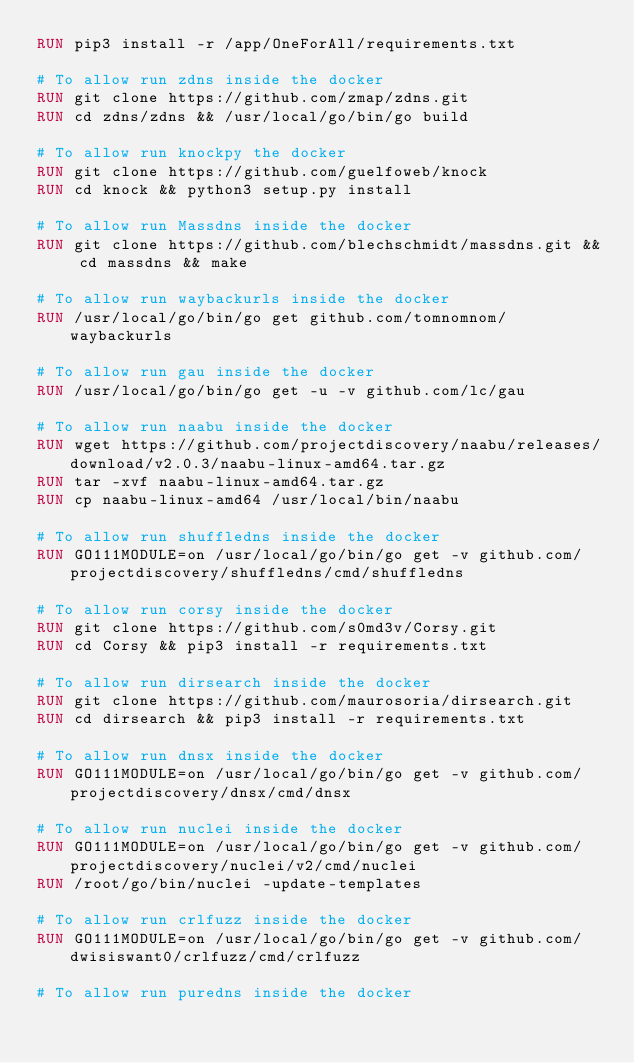<code> <loc_0><loc_0><loc_500><loc_500><_Dockerfile_>RUN pip3 install -r /app/OneForAll/requirements.txt

# To allow run zdns inside the docker
RUN git clone https://github.com/zmap/zdns.git
RUN cd zdns/zdns && /usr/local/go/bin/go build

# To allow run knockpy the docker
RUN git clone https://github.com/guelfoweb/knock
RUN cd knock && python3 setup.py install

# To allow run Massdns inside the docker
RUN git clone https://github.com/blechschmidt/massdns.git && cd massdns && make

# To allow run waybackurls inside the docker
RUN /usr/local/go/bin/go get github.com/tomnomnom/waybackurls

# To allow run gau inside the docker
RUN /usr/local/go/bin/go get -u -v github.com/lc/gau

# To allow run naabu inside the docker
RUN wget https://github.com/projectdiscovery/naabu/releases/download/v2.0.3/naabu-linux-amd64.tar.gz
RUN tar -xvf naabu-linux-amd64.tar.gz
RUN cp naabu-linux-amd64 /usr/local/bin/naabu

# To allow run shuffledns inside the docker
RUN GO111MODULE=on /usr/local/go/bin/go get -v github.com/projectdiscovery/shuffledns/cmd/shuffledns

# To allow run corsy inside the docker
RUN git clone https://github.com/s0md3v/Corsy.git
RUN cd Corsy && pip3 install -r requirements.txt

# To allow run dirsearch inside the docker
RUN git clone https://github.com/maurosoria/dirsearch.git
RUN cd dirsearch && pip3 install -r requirements.txt

# To allow run dnsx inside the docker
RUN GO111MODULE=on /usr/local/go/bin/go get -v github.com/projectdiscovery/dnsx/cmd/dnsx

# To allow run nuclei inside the docker
RUN GO111MODULE=on /usr/local/go/bin/go get -v github.com/projectdiscovery/nuclei/v2/cmd/nuclei 
RUN /root/go/bin/nuclei -update-templates

# To allow run crlfuzz inside the docker
RUN GO111MODULE=on /usr/local/go/bin/go get -v github.com/dwisiswant0/crlfuzz/cmd/crlfuzz

# To allow run puredns inside the docker</code> 